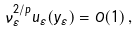Convert formula to latex. <formula><loc_0><loc_0><loc_500><loc_500>\nu _ { \varepsilon } ^ { 2 / p } u _ { \varepsilon } ( y _ { \varepsilon } ) = O ( 1 ) \, ,</formula> 